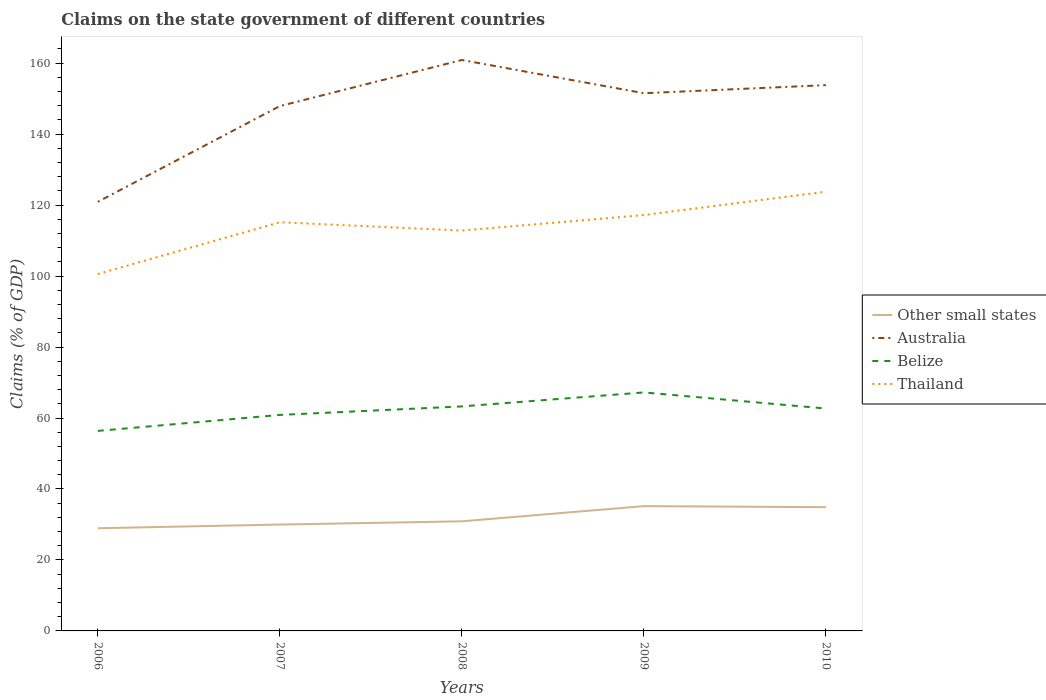How many different coloured lines are there?
Provide a succinct answer. 4. Does the line corresponding to Thailand intersect with the line corresponding to Australia?
Your answer should be compact. No. Is the number of lines equal to the number of legend labels?
Offer a very short reply. Yes. Across all years, what is the maximum percentage of GDP claimed on the state government in Thailand?
Provide a succinct answer. 100.58. In which year was the percentage of GDP claimed on the state government in Australia maximum?
Ensure brevity in your answer.  2006. What is the total percentage of GDP claimed on the state government in Australia in the graph?
Your response must be concise. 7.09. What is the difference between the highest and the second highest percentage of GDP claimed on the state government in Belize?
Make the answer very short. 10.85. How many lines are there?
Keep it short and to the point. 4. What is the difference between two consecutive major ticks on the Y-axis?
Ensure brevity in your answer.  20. Does the graph contain any zero values?
Give a very brief answer. No. Where does the legend appear in the graph?
Ensure brevity in your answer.  Center right. What is the title of the graph?
Keep it short and to the point. Claims on the state government of different countries. Does "Lebanon" appear as one of the legend labels in the graph?
Offer a terse response. No. What is the label or title of the Y-axis?
Your answer should be compact. Claims (% of GDP). What is the Claims (% of GDP) of Other small states in 2006?
Provide a succinct answer. 28.93. What is the Claims (% of GDP) in Australia in 2006?
Your answer should be very brief. 120.93. What is the Claims (% of GDP) in Belize in 2006?
Provide a succinct answer. 56.37. What is the Claims (% of GDP) of Thailand in 2006?
Provide a short and direct response. 100.58. What is the Claims (% of GDP) in Other small states in 2007?
Ensure brevity in your answer.  29.98. What is the Claims (% of GDP) in Australia in 2007?
Your answer should be very brief. 147.91. What is the Claims (% of GDP) in Belize in 2007?
Your response must be concise. 60.87. What is the Claims (% of GDP) of Thailand in 2007?
Keep it short and to the point. 115.17. What is the Claims (% of GDP) in Other small states in 2008?
Make the answer very short. 30.89. What is the Claims (% of GDP) in Australia in 2008?
Ensure brevity in your answer.  160.9. What is the Claims (% of GDP) in Belize in 2008?
Give a very brief answer. 63.27. What is the Claims (% of GDP) of Thailand in 2008?
Make the answer very short. 112.84. What is the Claims (% of GDP) in Other small states in 2009?
Offer a terse response. 35.17. What is the Claims (% of GDP) of Australia in 2009?
Provide a short and direct response. 151.54. What is the Claims (% of GDP) in Belize in 2009?
Ensure brevity in your answer.  67.22. What is the Claims (% of GDP) of Thailand in 2009?
Your response must be concise. 117.21. What is the Claims (% of GDP) of Other small states in 2010?
Ensure brevity in your answer.  34.88. What is the Claims (% of GDP) in Australia in 2010?
Provide a short and direct response. 153.82. What is the Claims (% of GDP) of Belize in 2010?
Provide a short and direct response. 62.67. What is the Claims (% of GDP) in Thailand in 2010?
Your response must be concise. 123.79. Across all years, what is the maximum Claims (% of GDP) in Other small states?
Offer a very short reply. 35.17. Across all years, what is the maximum Claims (% of GDP) in Australia?
Offer a very short reply. 160.9. Across all years, what is the maximum Claims (% of GDP) in Belize?
Offer a very short reply. 67.22. Across all years, what is the maximum Claims (% of GDP) of Thailand?
Ensure brevity in your answer.  123.79. Across all years, what is the minimum Claims (% of GDP) of Other small states?
Keep it short and to the point. 28.93. Across all years, what is the minimum Claims (% of GDP) of Australia?
Your response must be concise. 120.93. Across all years, what is the minimum Claims (% of GDP) in Belize?
Ensure brevity in your answer.  56.37. Across all years, what is the minimum Claims (% of GDP) of Thailand?
Keep it short and to the point. 100.58. What is the total Claims (% of GDP) of Other small states in the graph?
Make the answer very short. 159.85. What is the total Claims (% of GDP) of Australia in the graph?
Keep it short and to the point. 735.1. What is the total Claims (% of GDP) in Belize in the graph?
Give a very brief answer. 310.41. What is the total Claims (% of GDP) in Thailand in the graph?
Your response must be concise. 569.59. What is the difference between the Claims (% of GDP) of Other small states in 2006 and that in 2007?
Your answer should be very brief. -1.04. What is the difference between the Claims (% of GDP) in Australia in 2006 and that in 2007?
Your answer should be compact. -26.98. What is the difference between the Claims (% of GDP) of Belize in 2006 and that in 2007?
Provide a short and direct response. -4.5. What is the difference between the Claims (% of GDP) of Thailand in 2006 and that in 2007?
Ensure brevity in your answer.  -14.59. What is the difference between the Claims (% of GDP) of Other small states in 2006 and that in 2008?
Make the answer very short. -1.95. What is the difference between the Claims (% of GDP) of Australia in 2006 and that in 2008?
Your response must be concise. -39.97. What is the difference between the Claims (% of GDP) in Belize in 2006 and that in 2008?
Your answer should be very brief. -6.9. What is the difference between the Claims (% of GDP) in Thailand in 2006 and that in 2008?
Provide a short and direct response. -12.25. What is the difference between the Claims (% of GDP) in Other small states in 2006 and that in 2009?
Your answer should be compact. -6.24. What is the difference between the Claims (% of GDP) in Australia in 2006 and that in 2009?
Offer a very short reply. -30.61. What is the difference between the Claims (% of GDP) of Belize in 2006 and that in 2009?
Make the answer very short. -10.85. What is the difference between the Claims (% of GDP) of Thailand in 2006 and that in 2009?
Offer a terse response. -16.62. What is the difference between the Claims (% of GDP) in Other small states in 2006 and that in 2010?
Your answer should be compact. -5.94. What is the difference between the Claims (% of GDP) in Australia in 2006 and that in 2010?
Offer a terse response. -32.88. What is the difference between the Claims (% of GDP) of Belize in 2006 and that in 2010?
Your response must be concise. -6.31. What is the difference between the Claims (% of GDP) of Thailand in 2006 and that in 2010?
Make the answer very short. -23.21. What is the difference between the Claims (% of GDP) in Other small states in 2007 and that in 2008?
Provide a succinct answer. -0.91. What is the difference between the Claims (% of GDP) of Australia in 2007 and that in 2008?
Make the answer very short. -12.99. What is the difference between the Claims (% of GDP) of Belize in 2007 and that in 2008?
Provide a succinct answer. -2.4. What is the difference between the Claims (% of GDP) in Thailand in 2007 and that in 2008?
Give a very brief answer. 2.34. What is the difference between the Claims (% of GDP) in Other small states in 2007 and that in 2009?
Provide a short and direct response. -5.19. What is the difference between the Claims (% of GDP) of Australia in 2007 and that in 2009?
Provide a succinct answer. -3.62. What is the difference between the Claims (% of GDP) in Belize in 2007 and that in 2009?
Offer a terse response. -6.34. What is the difference between the Claims (% of GDP) of Thailand in 2007 and that in 2009?
Offer a terse response. -2.04. What is the difference between the Claims (% of GDP) in Other small states in 2007 and that in 2010?
Ensure brevity in your answer.  -4.9. What is the difference between the Claims (% of GDP) in Australia in 2007 and that in 2010?
Your answer should be very brief. -5.9. What is the difference between the Claims (% of GDP) in Belize in 2007 and that in 2010?
Your answer should be very brief. -1.8. What is the difference between the Claims (% of GDP) in Thailand in 2007 and that in 2010?
Offer a terse response. -8.62. What is the difference between the Claims (% of GDP) of Other small states in 2008 and that in 2009?
Your response must be concise. -4.28. What is the difference between the Claims (% of GDP) in Australia in 2008 and that in 2009?
Provide a succinct answer. 9.37. What is the difference between the Claims (% of GDP) of Belize in 2008 and that in 2009?
Make the answer very short. -3.94. What is the difference between the Claims (% of GDP) in Thailand in 2008 and that in 2009?
Offer a very short reply. -4.37. What is the difference between the Claims (% of GDP) in Other small states in 2008 and that in 2010?
Provide a short and direct response. -3.99. What is the difference between the Claims (% of GDP) in Australia in 2008 and that in 2010?
Ensure brevity in your answer.  7.09. What is the difference between the Claims (% of GDP) of Belize in 2008 and that in 2010?
Make the answer very short. 0.6. What is the difference between the Claims (% of GDP) in Thailand in 2008 and that in 2010?
Ensure brevity in your answer.  -10.95. What is the difference between the Claims (% of GDP) in Other small states in 2009 and that in 2010?
Your answer should be very brief. 0.3. What is the difference between the Claims (% of GDP) of Australia in 2009 and that in 2010?
Provide a succinct answer. -2.28. What is the difference between the Claims (% of GDP) of Belize in 2009 and that in 2010?
Ensure brevity in your answer.  4.54. What is the difference between the Claims (% of GDP) in Thailand in 2009 and that in 2010?
Your answer should be compact. -6.58. What is the difference between the Claims (% of GDP) of Other small states in 2006 and the Claims (% of GDP) of Australia in 2007?
Provide a succinct answer. -118.98. What is the difference between the Claims (% of GDP) in Other small states in 2006 and the Claims (% of GDP) in Belize in 2007?
Ensure brevity in your answer.  -31.94. What is the difference between the Claims (% of GDP) in Other small states in 2006 and the Claims (% of GDP) in Thailand in 2007?
Your answer should be very brief. -86.24. What is the difference between the Claims (% of GDP) of Australia in 2006 and the Claims (% of GDP) of Belize in 2007?
Make the answer very short. 60.06. What is the difference between the Claims (% of GDP) in Australia in 2006 and the Claims (% of GDP) in Thailand in 2007?
Offer a terse response. 5.76. What is the difference between the Claims (% of GDP) of Belize in 2006 and the Claims (% of GDP) of Thailand in 2007?
Give a very brief answer. -58.8. What is the difference between the Claims (% of GDP) in Other small states in 2006 and the Claims (% of GDP) in Australia in 2008?
Ensure brevity in your answer.  -131.97. What is the difference between the Claims (% of GDP) in Other small states in 2006 and the Claims (% of GDP) in Belize in 2008?
Your answer should be very brief. -34.34. What is the difference between the Claims (% of GDP) of Other small states in 2006 and the Claims (% of GDP) of Thailand in 2008?
Give a very brief answer. -83.9. What is the difference between the Claims (% of GDP) in Australia in 2006 and the Claims (% of GDP) in Belize in 2008?
Make the answer very short. 57.66. What is the difference between the Claims (% of GDP) in Australia in 2006 and the Claims (% of GDP) in Thailand in 2008?
Ensure brevity in your answer.  8.1. What is the difference between the Claims (% of GDP) of Belize in 2006 and the Claims (% of GDP) of Thailand in 2008?
Give a very brief answer. -56.47. What is the difference between the Claims (% of GDP) of Other small states in 2006 and the Claims (% of GDP) of Australia in 2009?
Offer a terse response. -122.6. What is the difference between the Claims (% of GDP) in Other small states in 2006 and the Claims (% of GDP) in Belize in 2009?
Offer a very short reply. -38.28. What is the difference between the Claims (% of GDP) of Other small states in 2006 and the Claims (% of GDP) of Thailand in 2009?
Offer a terse response. -88.27. What is the difference between the Claims (% of GDP) in Australia in 2006 and the Claims (% of GDP) in Belize in 2009?
Offer a terse response. 53.72. What is the difference between the Claims (% of GDP) in Australia in 2006 and the Claims (% of GDP) in Thailand in 2009?
Your answer should be compact. 3.72. What is the difference between the Claims (% of GDP) of Belize in 2006 and the Claims (% of GDP) of Thailand in 2009?
Your response must be concise. -60.84. What is the difference between the Claims (% of GDP) of Other small states in 2006 and the Claims (% of GDP) of Australia in 2010?
Your answer should be very brief. -124.88. What is the difference between the Claims (% of GDP) of Other small states in 2006 and the Claims (% of GDP) of Belize in 2010?
Offer a terse response. -33.74. What is the difference between the Claims (% of GDP) of Other small states in 2006 and the Claims (% of GDP) of Thailand in 2010?
Your answer should be compact. -94.85. What is the difference between the Claims (% of GDP) of Australia in 2006 and the Claims (% of GDP) of Belize in 2010?
Your answer should be compact. 58.26. What is the difference between the Claims (% of GDP) of Australia in 2006 and the Claims (% of GDP) of Thailand in 2010?
Provide a succinct answer. -2.86. What is the difference between the Claims (% of GDP) of Belize in 2006 and the Claims (% of GDP) of Thailand in 2010?
Give a very brief answer. -67.42. What is the difference between the Claims (% of GDP) in Other small states in 2007 and the Claims (% of GDP) in Australia in 2008?
Keep it short and to the point. -130.92. What is the difference between the Claims (% of GDP) of Other small states in 2007 and the Claims (% of GDP) of Belize in 2008?
Keep it short and to the point. -33.29. What is the difference between the Claims (% of GDP) of Other small states in 2007 and the Claims (% of GDP) of Thailand in 2008?
Provide a succinct answer. -82.86. What is the difference between the Claims (% of GDP) in Australia in 2007 and the Claims (% of GDP) in Belize in 2008?
Your answer should be compact. 84.64. What is the difference between the Claims (% of GDP) in Australia in 2007 and the Claims (% of GDP) in Thailand in 2008?
Your answer should be very brief. 35.08. What is the difference between the Claims (% of GDP) in Belize in 2007 and the Claims (% of GDP) in Thailand in 2008?
Your answer should be very brief. -51.96. What is the difference between the Claims (% of GDP) in Other small states in 2007 and the Claims (% of GDP) in Australia in 2009?
Offer a very short reply. -121.56. What is the difference between the Claims (% of GDP) of Other small states in 2007 and the Claims (% of GDP) of Belize in 2009?
Keep it short and to the point. -37.24. What is the difference between the Claims (% of GDP) of Other small states in 2007 and the Claims (% of GDP) of Thailand in 2009?
Your answer should be compact. -87.23. What is the difference between the Claims (% of GDP) of Australia in 2007 and the Claims (% of GDP) of Belize in 2009?
Your response must be concise. 80.7. What is the difference between the Claims (% of GDP) of Australia in 2007 and the Claims (% of GDP) of Thailand in 2009?
Offer a very short reply. 30.71. What is the difference between the Claims (% of GDP) of Belize in 2007 and the Claims (% of GDP) of Thailand in 2009?
Provide a succinct answer. -56.33. What is the difference between the Claims (% of GDP) in Other small states in 2007 and the Claims (% of GDP) in Australia in 2010?
Offer a very short reply. -123.84. What is the difference between the Claims (% of GDP) of Other small states in 2007 and the Claims (% of GDP) of Belize in 2010?
Offer a very short reply. -32.69. What is the difference between the Claims (% of GDP) in Other small states in 2007 and the Claims (% of GDP) in Thailand in 2010?
Your answer should be compact. -93.81. What is the difference between the Claims (% of GDP) in Australia in 2007 and the Claims (% of GDP) in Belize in 2010?
Your response must be concise. 85.24. What is the difference between the Claims (% of GDP) of Australia in 2007 and the Claims (% of GDP) of Thailand in 2010?
Ensure brevity in your answer.  24.12. What is the difference between the Claims (% of GDP) in Belize in 2007 and the Claims (% of GDP) in Thailand in 2010?
Make the answer very short. -62.92. What is the difference between the Claims (% of GDP) in Other small states in 2008 and the Claims (% of GDP) in Australia in 2009?
Ensure brevity in your answer.  -120.65. What is the difference between the Claims (% of GDP) of Other small states in 2008 and the Claims (% of GDP) of Belize in 2009?
Provide a succinct answer. -36.33. What is the difference between the Claims (% of GDP) in Other small states in 2008 and the Claims (% of GDP) in Thailand in 2009?
Your answer should be very brief. -86.32. What is the difference between the Claims (% of GDP) of Australia in 2008 and the Claims (% of GDP) of Belize in 2009?
Ensure brevity in your answer.  93.69. What is the difference between the Claims (% of GDP) in Australia in 2008 and the Claims (% of GDP) in Thailand in 2009?
Provide a short and direct response. 43.69. What is the difference between the Claims (% of GDP) in Belize in 2008 and the Claims (% of GDP) in Thailand in 2009?
Provide a short and direct response. -53.93. What is the difference between the Claims (% of GDP) of Other small states in 2008 and the Claims (% of GDP) of Australia in 2010?
Give a very brief answer. -122.93. What is the difference between the Claims (% of GDP) in Other small states in 2008 and the Claims (% of GDP) in Belize in 2010?
Make the answer very short. -31.79. What is the difference between the Claims (% of GDP) of Other small states in 2008 and the Claims (% of GDP) of Thailand in 2010?
Provide a succinct answer. -92.9. What is the difference between the Claims (% of GDP) in Australia in 2008 and the Claims (% of GDP) in Belize in 2010?
Make the answer very short. 98.23. What is the difference between the Claims (% of GDP) of Australia in 2008 and the Claims (% of GDP) of Thailand in 2010?
Provide a succinct answer. 37.11. What is the difference between the Claims (% of GDP) of Belize in 2008 and the Claims (% of GDP) of Thailand in 2010?
Your answer should be very brief. -60.52. What is the difference between the Claims (% of GDP) of Other small states in 2009 and the Claims (% of GDP) of Australia in 2010?
Keep it short and to the point. -118.65. What is the difference between the Claims (% of GDP) in Other small states in 2009 and the Claims (% of GDP) in Belize in 2010?
Keep it short and to the point. -27.5. What is the difference between the Claims (% of GDP) in Other small states in 2009 and the Claims (% of GDP) in Thailand in 2010?
Offer a terse response. -88.62. What is the difference between the Claims (% of GDP) of Australia in 2009 and the Claims (% of GDP) of Belize in 2010?
Give a very brief answer. 88.86. What is the difference between the Claims (% of GDP) of Australia in 2009 and the Claims (% of GDP) of Thailand in 2010?
Your answer should be compact. 27.75. What is the difference between the Claims (% of GDP) in Belize in 2009 and the Claims (% of GDP) in Thailand in 2010?
Make the answer very short. -56.57. What is the average Claims (% of GDP) in Other small states per year?
Your response must be concise. 31.97. What is the average Claims (% of GDP) of Australia per year?
Your answer should be compact. 147.02. What is the average Claims (% of GDP) in Belize per year?
Provide a short and direct response. 62.08. What is the average Claims (% of GDP) in Thailand per year?
Provide a succinct answer. 113.92. In the year 2006, what is the difference between the Claims (% of GDP) in Other small states and Claims (% of GDP) in Australia?
Provide a succinct answer. -92. In the year 2006, what is the difference between the Claims (% of GDP) in Other small states and Claims (% of GDP) in Belize?
Make the answer very short. -27.43. In the year 2006, what is the difference between the Claims (% of GDP) in Other small states and Claims (% of GDP) in Thailand?
Make the answer very short. -71.65. In the year 2006, what is the difference between the Claims (% of GDP) of Australia and Claims (% of GDP) of Belize?
Keep it short and to the point. 64.56. In the year 2006, what is the difference between the Claims (% of GDP) of Australia and Claims (% of GDP) of Thailand?
Offer a very short reply. 20.35. In the year 2006, what is the difference between the Claims (% of GDP) in Belize and Claims (% of GDP) in Thailand?
Ensure brevity in your answer.  -44.21. In the year 2007, what is the difference between the Claims (% of GDP) in Other small states and Claims (% of GDP) in Australia?
Your answer should be compact. -117.93. In the year 2007, what is the difference between the Claims (% of GDP) of Other small states and Claims (% of GDP) of Belize?
Give a very brief answer. -30.89. In the year 2007, what is the difference between the Claims (% of GDP) of Other small states and Claims (% of GDP) of Thailand?
Your answer should be compact. -85.19. In the year 2007, what is the difference between the Claims (% of GDP) of Australia and Claims (% of GDP) of Belize?
Ensure brevity in your answer.  87.04. In the year 2007, what is the difference between the Claims (% of GDP) in Australia and Claims (% of GDP) in Thailand?
Provide a succinct answer. 32.74. In the year 2007, what is the difference between the Claims (% of GDP) in Belize and Claims (% of GDP) in Thailand?
Provide a short and direct response. -54.3. In the year 2008, what is the difference between the Claims (% of GDP) in Other small states and Claims (% of GDP) in Australia?
Give a very brief answer. -130.01. In the year 2008, what is the difference between the Claims (% of GDP) in Other small states and Claims (% of GDP) in Belize?
Offer a terse response. -32.38. In the year 2008, what is the difference between the Claims (% of GDP) of Other small states and Claims (% of GDP) of Thailand?
Give a very brief answer. -81.95. In the year 2008, what is the difference between the Claims (% of GDP) in Australia and Claims (% of GDP) in Belize?
Provide a short and direct response. 97.63. In the year 2008, what is the difference between the Claims (% of GDP) in Australia and Claims (% of GDP) in Thailand?
Your answer should be very brief. 48.07. In the year 2008, what is the difference between the Claims (% of GDP) in Belize and Claims (% of GDP) in Thailand?
Keep it short and to the point. -49.56. In the year 2009, what is the difference between the Claims (% of GDP) in Other small states and Claims (% of GDP) in Australia?
Your answer should be compact. -116.37. In the year 2009, what is the difference between the Claims (% of GDP) in Other small states and Claims (% of GDP) in Belize?
Offer a terse response. -32.04. In the year 2009, what is the difference between the Claims (% of GDP) in Other small states and Claims (% of GDP) in Thailand?
Give a very brief answer. -82.04. In the year 2009, what is the difference between the Claims (% of GDP) of Australia and Claims (% of GDP) of Belize?
Provide a succinct answer. 84.32. In the year 2009, what is the difference between the Claims (% of GDP) of Australia and Claims (% of GDP) of Thailand?
Your answer should be very brief. 34.33. In the year 2009, what is the difference between the Claims (% of GDP) of Belize and Claims (% of GDP) of Thailand?
Give a very brief answer. -49.99. In the year 2010, what is the difference between the Claims (% of GDP) of Other small states and Claims (% of GDP) of Australia?
Provide a succinct answer. -118.94. In the year 2010, what is the difference between the Claims (% of GDP) in Other small states and Claims (% of GDP) in Belize?
Your response must be concise. -27.8. In the year 2010, what is the difference between the Claims (% of GDP) in Other small states and Claims (% of GDP) in Thailand?
Provide a succinct answer. -88.91. In the year 2010, what is the difference between the Claims (% of GDP) of Australia and Claims (% of GDP) of Belize?
Your answer should be very brief. 91.14. In the year 2010, what is the difference between the Claims (% of GDP) in Australia and Claims (% of GDP) in Thailand?
Keep it short and to the point. 30.03. In the year 2010, what is the difference between the Claims (% of GDP) of Belize and Claims (% of GDP) of Thailand?
Your response must be concise. -61.11. What is the ratio of the Claims (% of GDP) in Other small states in 2006 to that in 2007?
Offer a terse response. 0.97. What is the ratio of the Claims (% of GDP) of Australia in 2006 to that in 2007?
Give a very brief answer. 0.82. What is the ratio of the Claims (% of GDP) of Belize in 2006 to that in 2007?
Provide a short and direct response. 0.93. What is the ratio of the Claims (% of GDP) in Thailand in 2006 to that in 2007?
Give a very brief answer. 0.87. What is the ratio of the Claims (% of GDP) in Other small states in 2006 to that in 2008?
Provide a short and direct response. 0.94. What is the ratio of the Claims (% of GDP) of Australia in 2006 to that in 2008?
Your answer should be very brief. 0.75. What is the ratio of the Claims (% of GDP) of Belize in 2006 to that in 2008?
Offer a very short reply. 0.89. What is the ratio of the Claims (% of GDP) in Thailand in 2006 to that in 2008?
Make the answer very short. 0.89. What is the ratio of the Claims (% of GDP) in Other small states in 2006 to that in 2009?
Your response must be concise. 0.82. What is the ratio of the Claims (% of GDP) in Australia in 2006 to that in 2009?
Keep it short and to the point. 0.8. What is the ratio of the Claims (% of GDP) of Belize in 2006 to that in 2009?
Your answer should be very brief. 0.84. What is the ratio of the Claims (% of GDP) in Thailand in 2006 to that in 2009?
Offer a very short reply. 0.86. What is the ratio of the Claims (% of GDP) in Other small states in 2006 to that in 2010?
Ensure brevity in your answer.  0.83. What is the ratio of the Claims (% of GDP) in Australia in 2006 to that in 2010?
Your answer should be compact. 0.79. What is the ratio of the Claims (% of GDP) of Belize in 2006 to that in 2010?
Ensure brevity in your answer.  0.9. What is the ratio of the Claims (% of GDP) of Thailand in 2006 to that in 2010?
Provide a succinct answer. 0.81. What is the ratio of the Claims (% of GDP) in Other small states in 2007 to that in 2008?
Your response must be concise. 0.97. What is the ratio of the Claims (% of GDP) in Australia in 2007 to that in 2008?
Your answer should be very brief. 0.92. What is the ratio of the Claims (% of GDP) of Belize in 2007 to that in 2008?
Your response must be concise. 0.96. What is the ratio of the Claims (% of GDP) in Thailand in 2007 to that in 2008?
Offer a terse response. 1.02. What is the ratio of the Claims (% of GDP) of Other small states in 2007 to that in 2009?
Offer a very short reply. 0.85. What is the ratio of the Claims (% of GDP) of Australia in 2007 to that in 2009?
Your response must be concise. 0.98. What is the ratio of the Claims (% of GDP) of Belize in 2007 to that in 2009?
Ensure brevity in your answer.  0.91. What is the ratio of the Claims (% of GDP) of Thailand in 2007 to that in 2009?
Your response must be concise. 0.98. What is the ratio of the Claims (% of GDP) of Other small states in 2007 to that in 2010?
Ensure brevity in your answer.  0.86. What is the ratio of the Claims (% of GDP) of Australia in 2007 to that in 2010?
Your answer should be compact. 0.96. What is the ratio of the Claims (% of GDP) in Belize in 2007 to that in 2010?
Give a very brief answer. 0.97. What is the ratio of the Claims (% of GDP) of Thailand in 2007 to that in 2010?
Ensure brevity in your answer.  0.93. What is the ratio of the Claims (% of GDP) of Other small states in 2008 to that in 2009?
Your response must be concise. 0.88. What is the ratio of the Claims (% of GDP) of Australia in 2008 to that in 2009?
Provide a short and direct response. 1.06. What is the ratio of the Claims (% of GDP) of Belize in 2008 to that in 2009?
Your response must be concise. 0.94. What is the ratio of the Claims (% of GDP) in Thailand in 2008 to that in 2009?
Give a very brief answer. 0.96. What is the ratio of the Claims (% of GDP) in Other small states in 2008 to that in 2010?
Provide a short and direct response. 0.89. What is the ratio of the Claims (% of GDP) in Australia in 2008 to that in 2010?
Ensure brevity in your answer.  1.05. What is the ratio of the Claims (% of GDP) in Belize in 2008 to that in 2010?
Make the answer very short. 1.01. What is the ratio of the Claims (% of GDP) in Thailand in 2008 to that in 2010?
Offer a terse response. 0.91. What is the ratio of the Claims (% of GDP) of Other small states in 2009 to that in 2010?
Offer a terse response. 1.01. What is the ratio of the Claims (% of GDP) in Australia in 2009 to that in 2010?
Make the answer very short. 0.99. What is the ratio of the Claims (% of GDP) in Belize in 2009 to that in 2010?
Provide a short and direct response. 1.07. What is the ratio of the Claims (% of GDP) of Thailand in 2009 to that in 2010?
Your response must be concise. 0.95. What is the difference between the highest and the second highest Claims (% of GDP) in Other small states?
Ensure brevity in your answer.  0.3. What is the difference between the highest and the second highest Claims (% of GDP) of Australia?
Give a very brief answer. 7.09. What is the difference between the highest and the second highest Claims (% of GDP) in Belize?
Offer a very short reply. 3.94. What is the difference between the highest and the second highest Claims (% of GDP) of Thailand?
Your response must be concise. 6.58. What is the difference between the highest and the lowest Claims (% of GDP) of Other small states?
Your response must be concise. 6.24. What is the difference between the highest and the lowest Claims (% of GDP) of Australia?
Give a very brief answer. 39.97. What is the difference between the highest and the lowest Claims (% of GDP) of Belize?
Your response must be concise. 10.85. What is the difference between the highest and the lowest Claims (% of GDP) in Thailand?
Your answer should be very brief. 23.21. 